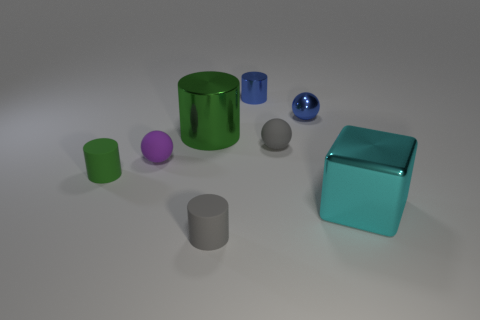Is there anything else that is made of the same material as the tiny gray sphere?
Keep it short and to the point. Yes. There is a green object that is behind the green thing that is on the left side of the big green cylinder; is there a small green object that is behind it?
Your answer should be compact. No. What is the material of the cylinder that is behind the shiny ball?
Offer a terse response. Metal. How many tiny things are either red metallic spheres or shiny balls?
Provide a short and direct response. 1. There is a gray matte cylinder in front of the blue metallic sphere; is it the same size as the tiny green rubber cylinder?
Make the answer very short. Yes. What number of other things are there of the same color as the metal block?
Make the answer very short. 0. What material is the tiny gray sphere?
Keep it short and to the point. Rubber. There is a tiny cylinder that is both in front of the tiny blue ball and behind the big cyan thing; what material is it?
Make the answer very short. Rubber. How many things are either small things behind the tiny green rubber thing or gray matte cylinders?
Offer a terse response. 5. Does the big metal cube have the same color as the metallic sphere?
Your answer should be very brief. No. 